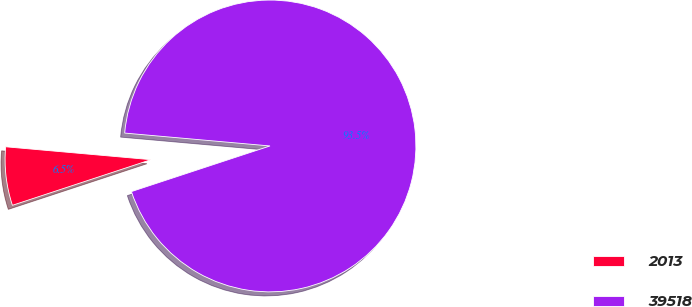Convert chart to OTSL. <chart><loc_0><loc_0><loc_500><loc_500><pie_chart><fcel>2013<fcel>39518<nl><fcel>6.47%<fcel>93.53%<nl></chart> 